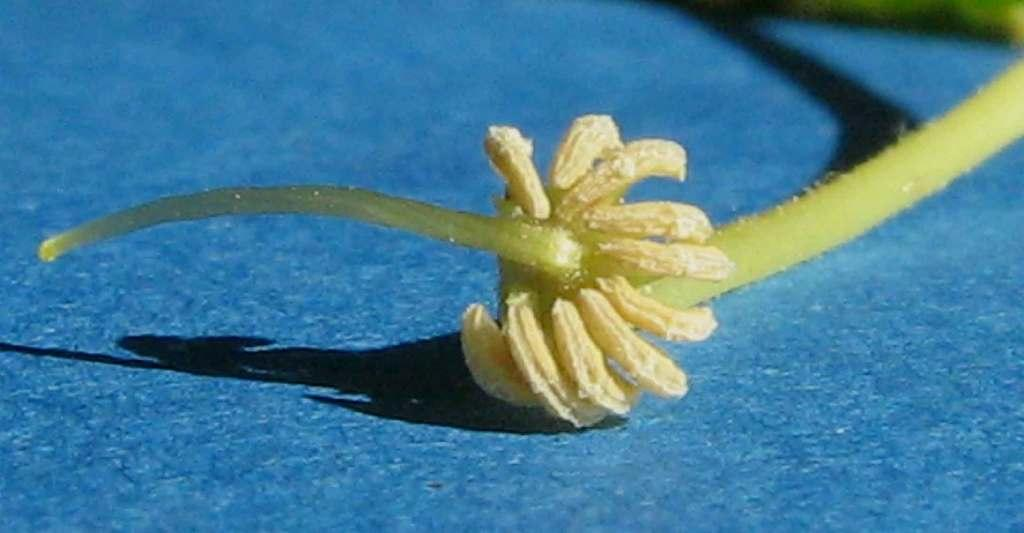What is the main subject of the image? There is a flower in the image. Where is the flower located in the image? The flower is in the center of the image. What color is the surface beneath the flower? The surface beneath the flower is blue. How many cherries are on the face in the image? There is no face or cherries present in the image; it features a flower on a blue surface. 